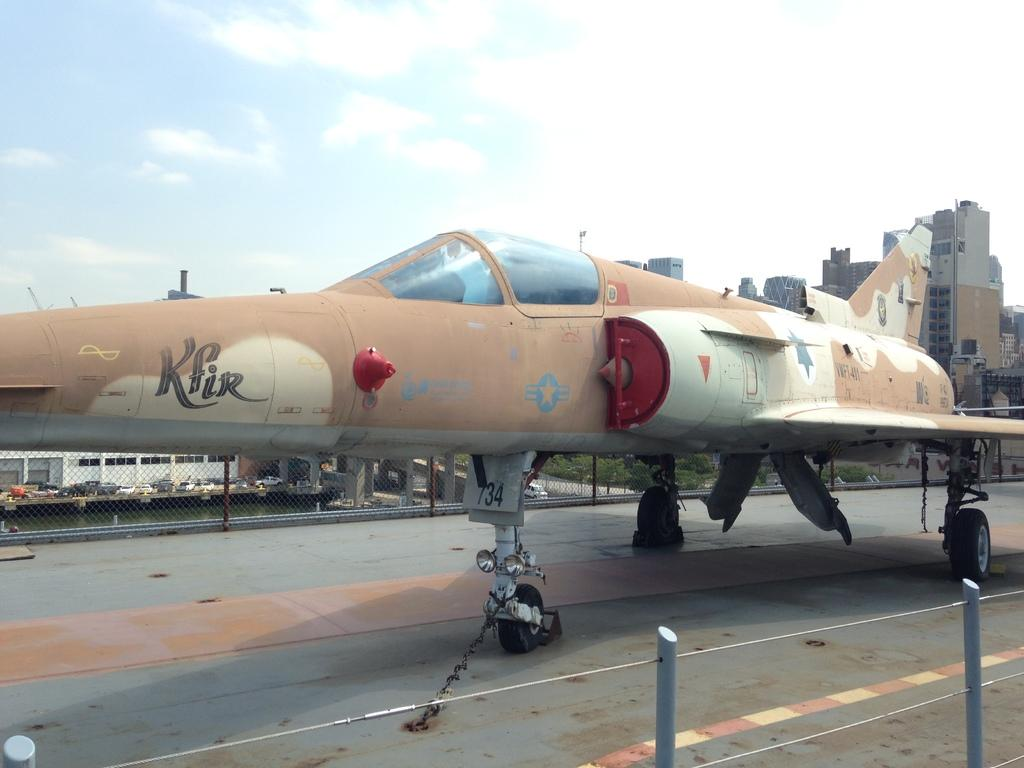<image>
Render a clear and concise summary of the photo. a brown and cream colored airplane with kfir on the side 